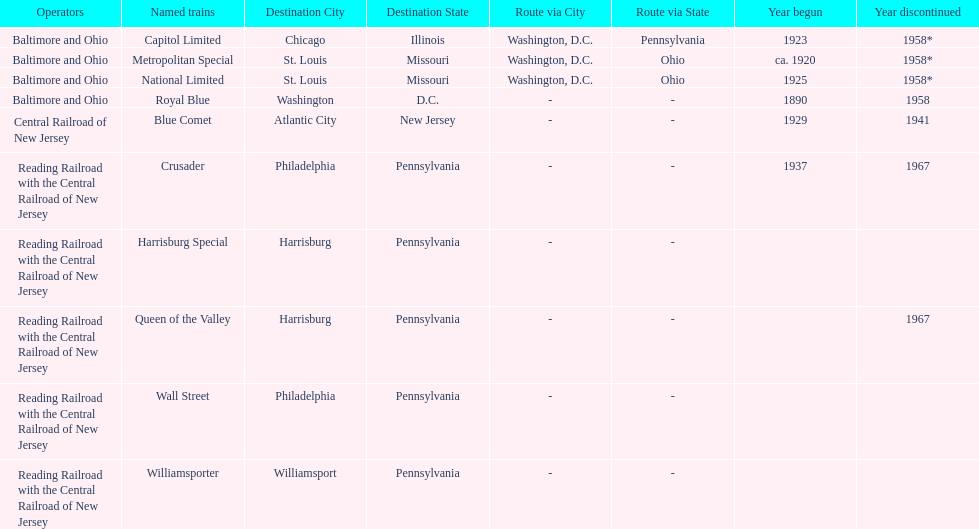What is the total number of year begun? 6. 